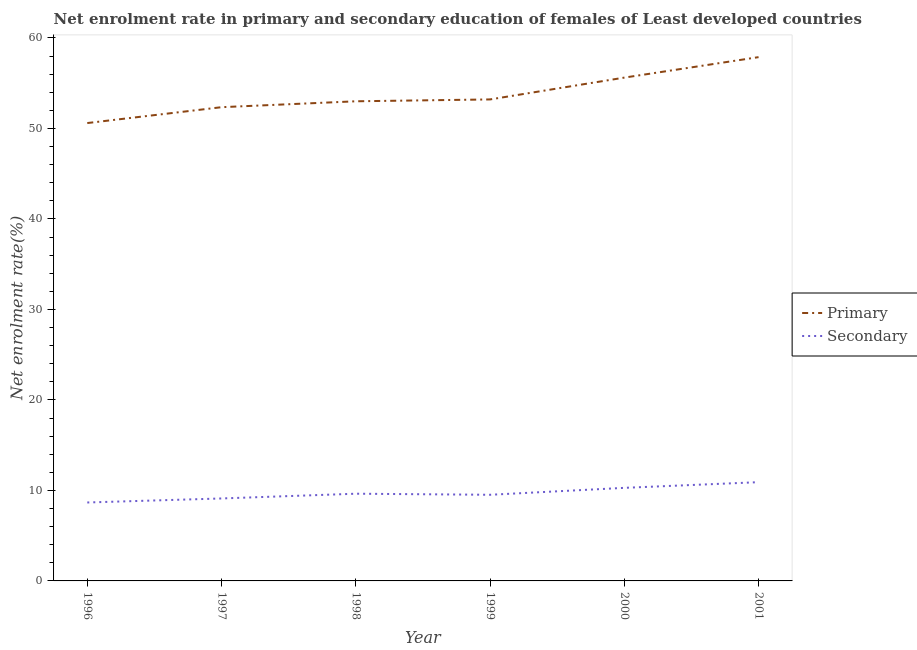What is the enrollment rate in primary education in 1996?
Give a very brief answer. 50.6. Across all years, what is the maximum enrollment rate in primary education?
Provide a succinct answer. 57.88. Across all years, what is the minimum enrollment rate in secondary education?
Your answer should be very brief. 8.67. In which year was the enrollment rate in primary education minimum?
Your answer should be very brief. 1996. What is the total enrollment rate in primary education in the graph?
Your response must be concise. 322.67. What is the difference between the enrollment rate in secondary education in 1997 and that in 2000?
Keep it short and to the point. -1.17. What is the difference between the enrollment rate in primary education in 1999 and the enrollment rate in secondary education in 1998?
Ensure brevity in your answer.  43.57. What is the average enrollment rate in primary education per year?
Ensure brevity in your answer.  53.78. In the year 1997, what is the difference between the enrollment rate in secondary education and enrollment rate in primary education?
Ensure brevity in your answer.  -43.24. What is the ratio of the enrollment rate in primary education in 1998 to that in 1999?
Your response must be concise. 1. Is the enrollment rate in primary education in 1997 less than that in 1998?
Keep it short and to the point. Yes. Is the difference between the enrollment rate in primary education in 1998 and 1999 greater than the difference between the enrollment rate in secondary education in 1998 and 1999?
Your answer should be compact. No. What is the difference between the highest and the second highest enrollment rate in primary education?
Your response must be concise. 2.26. What is the difference between the highest and the lowest enrollment rate in primary education?
Offer a very short reply. 7.28. In how many years, is the enrollment rate in secondary education greater than the average enrollment rate in secondary education taken over all years?
Offer a very short reply. 2. Is the sum of the enrollment rate in secondary education in 1996 and 1997 greater than the maximum enrollment rate in primary education across all years?
Keep it short and to the point. No. Is the enrollment rate in primary education strictly greater than the enrollment rate in secondary education over the years?
Give a very brief answer. Yes. Is the enrollment rate in secondary education strictly less than the enrollment rate in primary education over the years?
Ensure brevity in your answer.  Yes. How many years are there in the graph?
Offer a terse response. 6. What is the difference between two consecutive major ticks on the Y-axis?
Your answer should be very brief. 10. Does the graph contain any zero values?
Make the answer very short. No. Where does the legend appear in the graph?
Your answer should be compact. Center right. How many legend labels are there?
Offer a very short reply. 2. What is the title of the graph?
Provide a short and direct response. Net enrolment rate in primary and secondary education of females of Least developed countries. What is the label or title of the Y-axis?
Make the answer very short. Net enrolment rate(%). What is the Net enrolment rate(%) in Primary in 1996?
Your answer should be compact. 50.6. What is the Net enrolment rate(%) of Secondary in 1996?
Ensure brevity in your answer.  8.67. What is the Net enrolment rate(%) in Primary in 1997?
Provide a short and direct response. 52.35. What is the Net enrolment rate(%) in Secondary in 1997?
Provide a short and direct response. 9.11. What is the Net enrolment rate(%) in Primary in 1998?
Provide a succinct answer. 53. What is the Net enrolment rate(%) in Secondary in 1998?
Keep it short and to the point. 9.64. What is the Net enrolment rate(%) of Primary in 1999?
Make the answer very short. 53.21. What is the Net enrolment rate(%) of Secondary in 1999?
Provide a succinct answer. 9.52. What is the Net enrolment rate(%) of Primary in 2000?
Your answer should be very brief. 55.62. What is the Net enrolment rate(%) of Secondary in 2000?
Give a very brief answer. 10.29. What is the Net enrolment rate(%) of Primary in 2001?
Make the answer very short. 57.88. What is the Net enrolment rate(%) in Secondary in 2001?
Provide a succinct answer. 10.91. Across all years, what is the maximum Net enrolment rate(%) in Primary?
Provide a succinct answer. 57.88. Across all years, what is the maximum Net enrolment rate(%) in Secondary?
Offer a very short reply. 10.91. Across all years, what is the minimum Net enrolment rate(%) of Primary?
Offer a terse response. 50.6. Across all years, what is the minimum Net enrolment rate(%) in Secondary?
Your response must be concise. 8.67. What is the total Net enrolment rate(%) in Primary in the graph?
Ensure brevity in your answer.  322.67. What is the total Net enrolment rate(%) in Secondary in the graph?
Keep it short and to the point. 58.14. What is the difference between the Net enrolment rate(%) in Primary in 1996 and that in 1997?
Provide a succinct answer. -1.75. What is the difference between the Net enrolment rate(%) in Secondary in 1996 and that in 1997?
Your answer should be very brief. -0.45. What is the difference between the Net enrolment rate(%) in Primary in 1996 and that in 1998?
Provide a succinct answer. -2.41. What is the difference between the Net enrolment rate(%) in Secondary in 1996 and that in 1998?
Keep it short and to the point. -0.97. What is the difference between the Net enrolment rate(%) of Primary in 1996 and that in 1999?
Your answer should be very brief. -2.61. What is the difference between the Net enrolment rate(%) in Secondary in 1996 and that in 1999?
Offer a very short reply. -0.85. What is the difference between the Net enrolment rate(%) of Primary in 1996 and that in 2000?
Your answer should be compact. -5.02. What is the difference between the Net enrolment rate(%) of Secondary in 1996 and that in 2000?
Provide a short and direct response. -1.62. What is the difference between the Net enrolment rate(%) in Primary in 1996 and that in 2001?
Give a very brief answer. -7.28. What is the difference between the Net enrolment rate(%) in Secondary in 1996 and that in 2001?
Your response must be concise. -2.24. What is the difference between the Net enrolment rate(%) in Primary in 1997 and that in 1998?
Provide a short and direct response. -0.65. What is the difference between the Net enrolment rate(%) in Secondary in 1997 and that in 1998?
Provide a succinct answer. -0.52. What is the difference between the Net enrolment rate(%) of Primary in 1997 and that in 1999?
Offer a very short reply. -0.86. What is the difference between the Net enrolment rate(%) of Secondary in 1997 and that in 1999?
Provide a succinct answer. -0.41. What is the difference between the Net enrolment rate(%) in Primary in 1997 and that in 2000?
Provide a succinct answer. -3.27. What is the difference between the Net enrolment rate(%) of Secondary in 1997 and that in 2000?
Your response must be concise. -1.17. What is the difference between the Net enrolment rate(%) in Primary in 1997 and that in 2001?
Provide a succinct answer. -5.53. What is the difference between the Net enrolment rate(%) of Secondary in 1997 and that in 2001?
Keep it short and to the point. -1.8. What is the difference between the Net enrolment rate(%) of Primary in 1998 and that in 1999?
Offer a very short reply. -0.21. What is the difference between the Net enrolment rate(%) of Secondary in 1998 and that in 1999?
Give a very brief answer. 0.12. What is the difference between the Net enrolment rate(%) of Primary in 1998 and that in 2000?
Ensure brevity in your answer.  -2.62. What is the difference between the Net enrolment rate(%) of Secondary in 1998 and that in 2000?
Provide a succinct answer. -0.65. What is the difference between the Net enrolment rate(%) in Primary in 1998 and that in 2001?
Your answer should be compact. -4.88. What is the difference between the Net enrolment rate(%) in Secondary in 1998 and that in 2001?
Ensure brevity in your answer.  -1.28. What is the difference between the Net enrolment rate(%) in Primary in 1999 and that in 2000?
Your answer should be compact. -2.41. What is the difference between the Net enrolment rate(%) in Secondary in 1999 and that in 2000?
Provide a short and direct response. -0.77. What is the difference between the Net enrolment rate(%) of Primary in 1999 and that in 2001?
Your response must be concise. -4.67. What is the difference between the Net enrolment rate(%) of Secondary in 1999 and that in 2001?
Keep it short and to the point. -1.39. What is the difference between the Net enrolment rate(%) of Primary in 2000 and that in 2001?
Keep it short and to the point. -2.26. What is the difference between the Net enrolment rate(%) in Secondary in 2000 and that in 2001?
Offer a terse response. -0.63. What is the difference between the Net enrolment rate(%) in Primary in 1996 and the Net enrolment rate(%) in Secondary in 1997?
Offer a terse response. 41.49. What is the difference between the Net enrolment rate(%) of Primary in 1996 and the Net enrolment rate(%) of Secondary in 1998?
Your answer should be very brief. 40.96. What is the difference between the Net enrolment rate(%) of Primary in 1996 and the Net enrolment rate(%) of Secondary in 1999?
Make the answer very short. 41.08. What is the difference between the Net enrolment rate(%) in Primary in 1996 and the Net enrolment rate(%) in Secondary in 2000?
Your answer should be compact. 40.31. What is the difference between the Net enrolment rate(%) in Primary in 1996 and the Net enrolment rate(%) in Secondary in 2001?
Your response must be concise. 39.69. What is the difference between the Net enrolment rate(%) in Primary in 1997 and the Net enrolment rate(%) in Secondary in 1998?
Provide a succinct answer. 42.72. What is the difference between the Net enrolment rate(%) in Primary in 1997 and the Net enrolment rate(%) in Secondary in 1999?
Offer a very short reply. 42.83. What is the difference between the Net enrolment rate(%) in Primary in 1997 and the Net enrolment rate(%) in Secondary in 2000?
Ensure brevity in your answer.  42.07. What is the difference between the Net enrolment rate(%) of Primary in 1997 and the Net enrolment rate(%) of Secondary in 2001?
Your answer should be very brief. 41.44. What is the difference between the Net enrolment rate(%) in Primary in 1998 and the Net enrolment rate(%) in Secondary in 1999?
Make the answer very short. 43.49. What is the difference between the Net enrolment rate(%) in Primary in 1998 and the Net enrolment rate(%) in Secondary in 2000?
Offer a terse response. 42.72. What is the difference between the Net enrolment rate(%) in Primary in 1998 and the Net enrolment rate(%) in Secondary in 2001?
Keep it short and to the point. 42.09. What is the difference between the Net enrolment rate(%) of Primary in 1999 and the Net enrolment rate(%) of Secondary in 2000?
Give a very brief answer. 42.92. What is the difference between the Net enrolment rate(%) of Primary in 1999 and the Net enrolment rate(%) of Secondary in 2001?
Offer a very short reply. 42.3. What is the difference between the Net enrolment rate(%) in Primary in 2000 and the Net enrolment rate(%) in Secondary in 2001?
Provide a short and direct response. 44.71. What is the average Net enrolment rate(%) in Primary per year?
Offer a terse response. 53.78. What is the average Net enrolment rate(%) of Secondary per year?
Give a very brief answer. 9.69. In the year 1996, what is the difference between the Net enrolment rate(%) in Primary and Net enrolment rate(%) in Secondary?
Offer a terse response. 41.93. In the year 1997, what is the difference between the Net enrolment rate(%) in Primary and Net enrolment rate(%) in Secondary?
Your answer should be very brief. 43.24. In the year 1998, what is the difference between the Net enrolment rate(%) of Primary and Net enrolment rate(%) of Secondary?
Ensure brevity in your answer.  43.37. In the year 1999, what is the difference between the Net enrolment rate(%) in Primary and Net enrolment rate(%) in Secondary?
Your answer should be compact. 43.69. In the year 2000, what is the difference between the Net enrolment rate(%) of Primary and Net enrolment rate(%) of Secondary?
Your answer should be compact. 45.34. In the year 2001, what is the difference between the Net enrolment rate(%) in Primary and Net enrolment rate(%) in Secondary?
Give a very brief answer. 46.97. What is the ratio of the Net enrolment rate(%) of Primary in 1996 to that in 1997?
Your answer should be compact. 0.97. What is the ratio of the Net enrolment rate(%) in Secondary in 1996 to that in 1997?
Offer a terse response. 0.95. What is the ratio of the Net enrolment rate(%) in Primary in 1996 to that in 1998?
Make the answer very short. 0.95. What is the ratio of the Net enrolment rate(%) of Secondary in 1996 to that in 1998?
Provide a succinct answer. 0.9. What is the ratio of the Net enrolment rate(%) of Primary in 1996 to that in 1999?
Offer a terse response. 0.95. What is the ratio of the Net enrolment rate(%) in Secondary in 1996 to that in 1999?
Provide a succinct answer. 0.91. What is the ratio of the Net enrolment rate(%) in Primary in 1996 to that in 2000?
Your answer should be compact. 0.91. What is the ratio of the Net enrolment rate(%) in Secondary in 1996 to that in 2000?
Your answer should be very brief. 0.84. What is the ratio of the Net enrolment rate(%) of Primary in 1996 to that in 2001?
Ensure brevity in your answer.  0.87. What is the ratio of the Net enrolment rate(%) in Secondary in 1996 to that in 2001?
Keep it short and to the point. 0.79. What is the ratio of the Net enrolment rate(%) in Secondary in 1997 to that in 1998?
Ensure brevity in your answer.  0.95. What is the ratio of the Net enrolment rate(%) of Primary in 1997 to that in 1999?
Give a very brief answer. 0.98. What is the ratio of the Net enrolment rate(%) of Secondary in 1997 to that in 1999?
Give a very brief answer. 0.96. What is the ratio of the Net enrolment rate(%) in Primary in 1997 to that in 2000?
Your answer should be very brief. 0.94. What is the ratio of the Net enrolment rate(%) of Secondary in 1997 to that in 2000?
Offer a very short reply. 0.89. What is the ratio of the Net enrolment rate(%) in Primary in 1997 to that in 2001?
Give a very brief answer. 0.9. What is the ratio of the Net enrolment rate(%) in Secondary in 1997 to that in 2001?
Provide a short and direct response. 0.84. What is the ratio of the Net enrolment rate(%) of Primary in 1998 to that in 1999?
Provide a short and direct response. 1. What is the ratio of the Net enrolment rate(%) of Secondary in 1998 to that in 1999?
Make the answer very short. 1.01. What is the ratio of the Net enrolment rate(%) of Primary in 1998 to that in 2000?
Offer a terse response. 0.95. What is the ratio of the Net enrolment rate(%) in Secondary in 1998 to that in 2000?
Make the answer very short. 0.94. What is the ratio of the Net enrolment rate(%) of Primary in 1998 to that in 2001?
Your response must be concise. 0.92. What is the ratio of the Net enrolment rate(%) in Secondary in 1998 to that in 2001?
Your response must be concise. 0.88. What is the ratio of the Net enrolment rate(%) in Primary in 1999 to that in 2000?
Your answer should be very brief. 0.96. What is the ratio of the Net enrolment rate(%) in Secondary in 1999 to that in 2000?
Make the answer very short. 0.93. What is the ratio of the Net enrolment rate(%) in Primary in 1999 to that in 2001?
Offer a terse response. 0.92. What is the ratio of the Net enrolment rate(%) of Secondary in 1999 to that in 2001?
Provide a short and direct response. 0.87. What is the ratio of the Net enrolment rate(%) of Primary in 2000 to that in 2001?
Offer a terse response. 0.96. What is the ratio of the Net enrolment rate(%) in Secondary in 2000 to that in 2001?
Provide a succinct answer. 0.94. What is the difference between the highest and the second highest Net enrolment rate(%) of Primary?
Provide a succinct answer. 2.26. What is the difference between the highest and the second highest Net enrolment rate(%) of Secondary?
Your answer should be compact. 0.63. What is the difference between the highest and the lowest Net enrolment rate(%) in Primary?
Ensure brevity in your answer.  7.28. What is the difference between the highest and the lowest Net enrolment rate(%) of Secondary?
Make the answer very short. 2.24. 